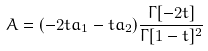<formula> <loc_0><loc_0><loc_500><loc_500>A = ( - 2 t a _ { 1 } - t a _ { 2 } ) \frac { \Gamma [ - 2 t ] } { \Gamma [ 1 - t ] ^ { 2 } }</formula> 